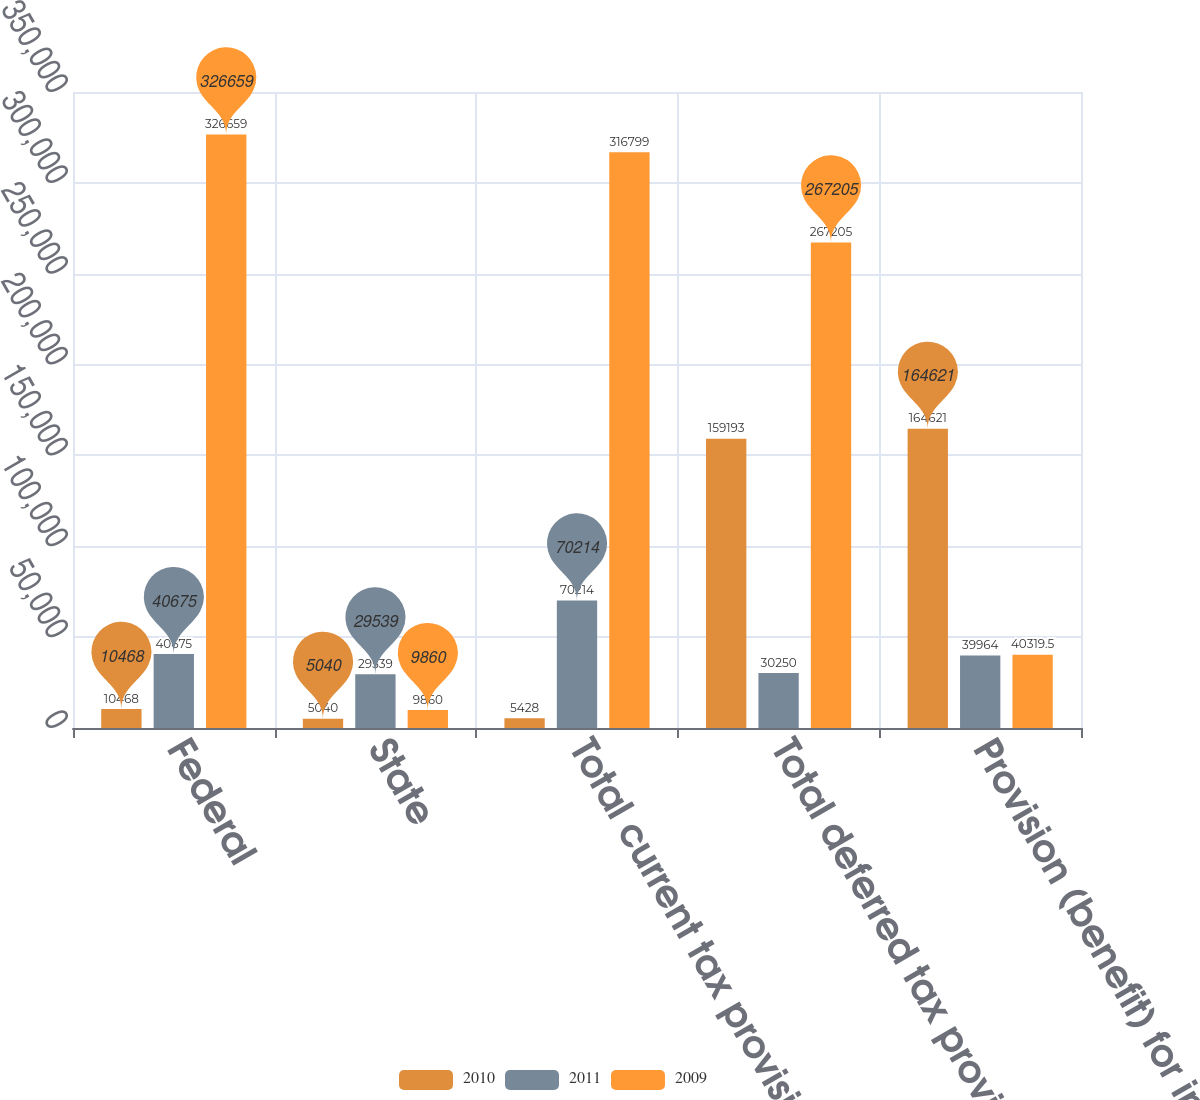<chart> <loc_0><loc_0><loc_500><loc_500><stacked_bar_chart><ecel><fcel>Federal<fcel>State<fcel>Total current tax provision<fcel>Total deferred tax provision<fcel>Provision (benefit) for income<nl><fcel>2010<fcel>10468<fcel>5040<fcel>5428<fcel>159193<fcel>164621<nl><fcel>2011<fcel>40675<fcel>29539<fcel>70214<fcel>30250<fcel>39964<nl><fcel>2009<fcel>326659<fcel>9860<fcel>316799<fcel>267205<fcel>40319.5<nl></chart> 